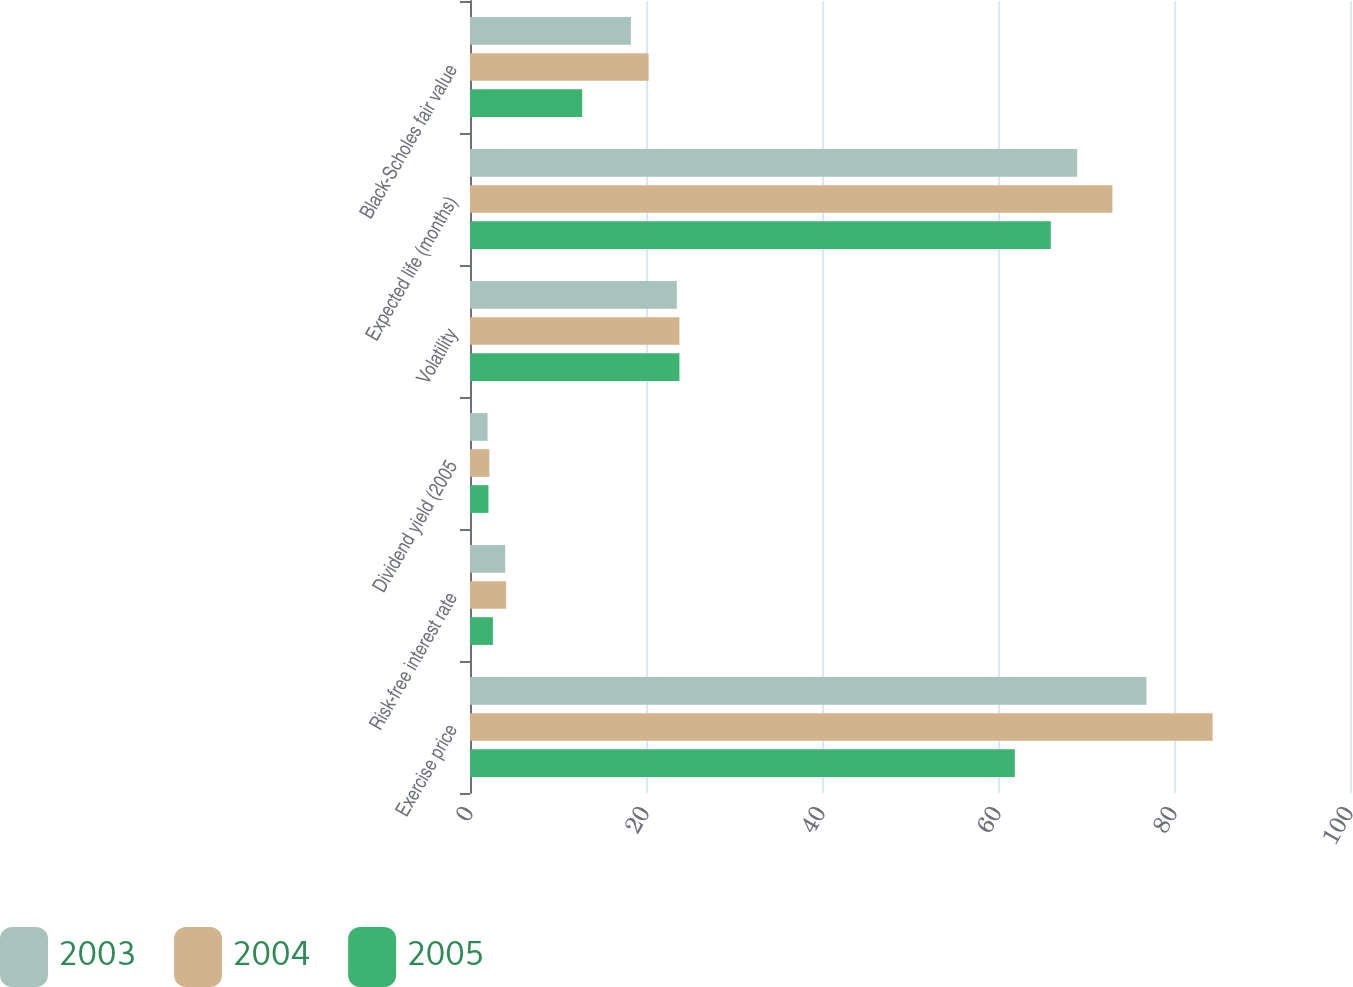<chart> <loc_0><loc_0><loc_500><loc_500><stacked_bar_chart><ecel><fcel>Exercise price<fcel>Risk-free interest rate<fcel>Dividend yield (2005<fcel>Volatility<fcel>Expected life (months)<fcel>Black-Scholes fair value<nl><fcel>2003<fcel>76.87<fcel>4<fcel>2<fcel>23.5<fcel>69<fcel>18.28<nl><fcel>2004<fcel>84.39<fcel>4.1<fcel>2.2<fcel>23.8<fcel>73<fcel>20.3<nl><fcel>2005<fcel>61.91<fcel>2.6<fcel>2.1<fcel>23.8<fcel>66<fcel>12.75<nl></chart> 